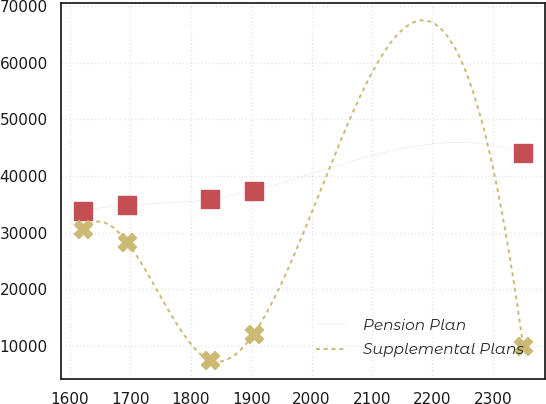<chart> <loc_0><loc_0><loc_500><loc_500><line_chart><ecel><fcel>Pension Plan<fcel>Supplemental Plans<nl><fcel>1621.64<fcel>33857.3<fcel>30582.5<nl><fcel>1694.51<fcel>34873.9<fcel>28354.8<nl><fcel>1831.65<fcel>35890.4<fcel>7527.07<nl><fcel>1904.52<fcel>37445.6<fcel>12192.1<nl><fcel>2350.3<fcel>44022.8<fcel>9964.44<nl></chart> 